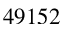<formula> <loc_0><loc_0><loc_500><loc_500>4 9 1 5 2</formula> 